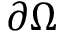<formula> <loc_0><loc_0><loc_500><loc_500>\partial \Omega</formula> 